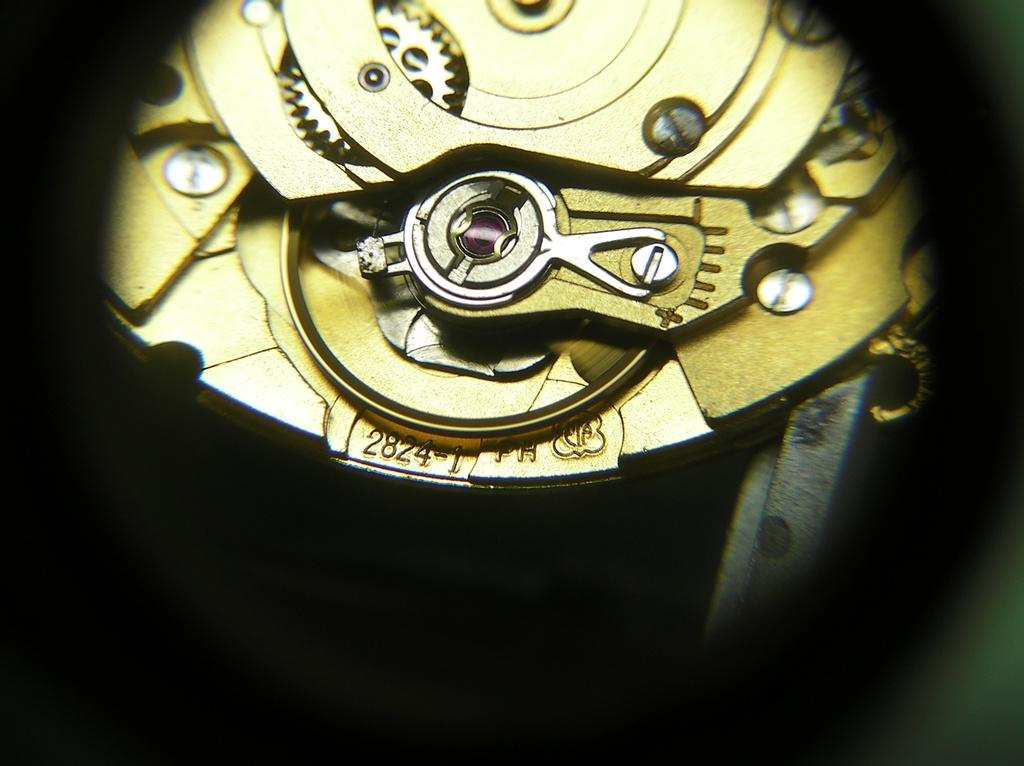<image>
Give a short and clear explanation of the subsequent image. Exposed metallic gold watch cogs and gears, serial number 2824-1 